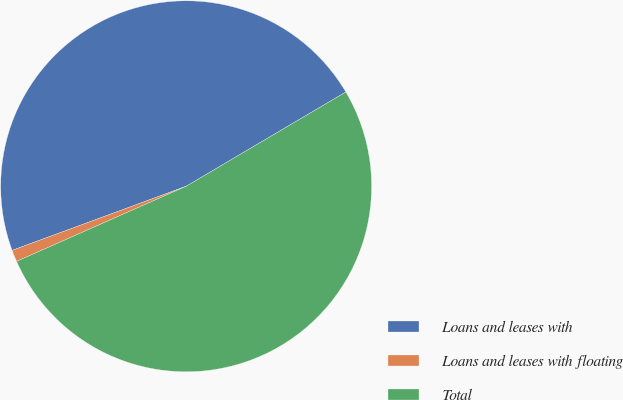Convert chart to OTSL. <chart><loc_0><loc_0><loc_500><loc_500><pie_chart><fcel>Loans and leases with<fcel>Loans and leases with floating<fcel>Total<nl><fcel>47.13%<fcel>1.02%<fcel>51.85%<nl></chart> 